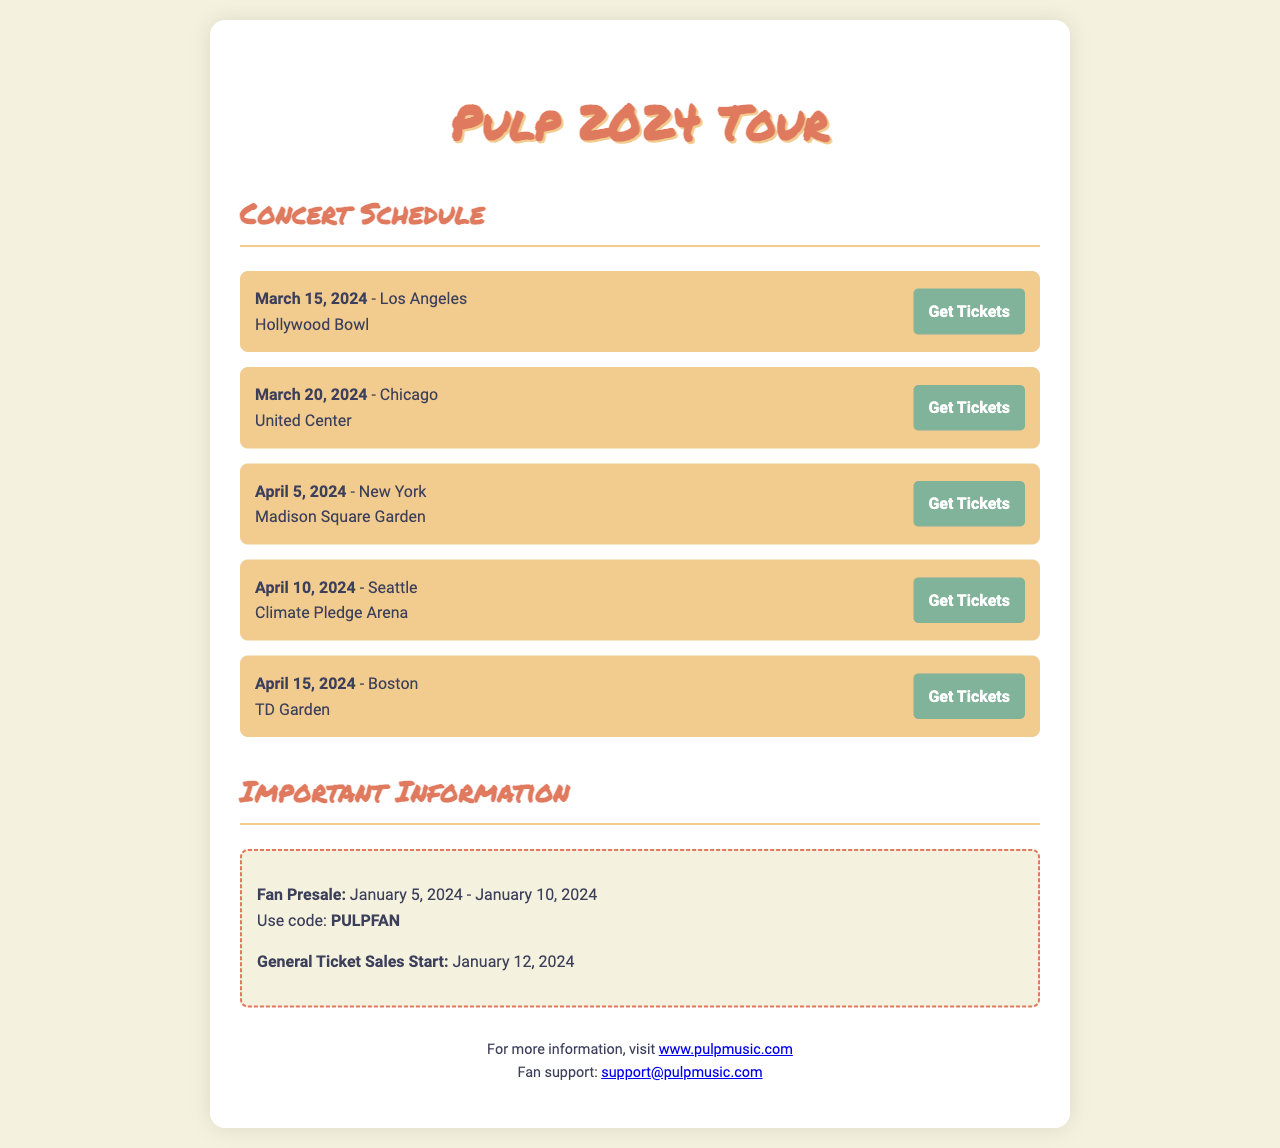What is the date of the concert in Los Angeles? The concert in Los Angeles is scheduled for March 15, 2024.
Answer: March 15, 2024 Where will the Boston concert take place? The Boston concert will take place at TD Garden.
Answer: TD Garden What is the presale access code for fans? The presale access code for fans is mentioned in the document.
Answer: PULPFAN When do general ticket sales start? General ticket sales start on January 12, 2024.
Answer: January 12, 2024 How many concerts are listed in the schedule? The number of concerts can be counted from the list in the document.
Answer: Five On what date is the concert in Seattle? The concert in Seattle is occurring on April 10, 2024.
Answer: April 10, 2024 What venue is associated with the New York concert? The venue for the New York concert is specified in the document.
Answer: Madison Square Garden What is the email address for fan support? The email address for fan support is provided toward the end of the letter.
Answer: support@pulpmusic.com What is the color of the highlight box in the "Important Information" section? The color of the highlight box can be inferred from the document’s design details.
Answer: Dashed pink 